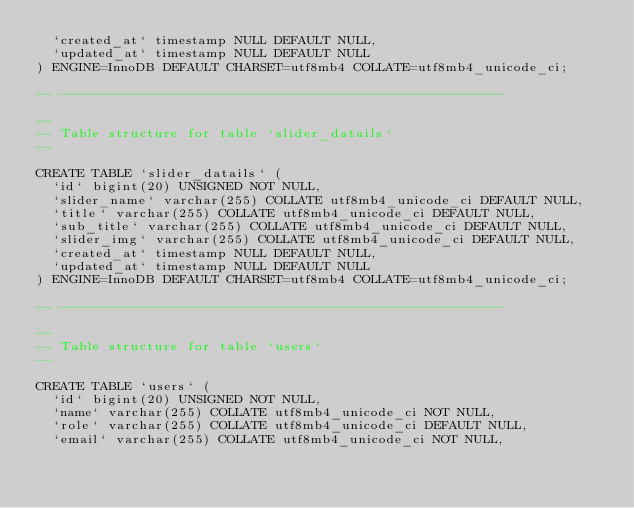<code> <loc_0><loc_0><loc_500><loc_500><_SQL_>  `created_at` timestamp NULL DEFAULT NULL,
  `updated_at` timestamp NULL DEFAULT NULL
) ENGINE=InnoDB DEFAULT CHARSET=utf8mb4 COLLATE=utf8mb4_unicode_ci;

-- --------------------------------------------------------

--
-- Table structure for table `slider_datails`
--

CREATE TABLE `slider_datails` (
  `id` bigint(20) UNSIGNED NOT NULL,
  `slider_name` varchar(255) COLLATE utf8mb4_unicode_ci DEFAULT NULL,
  `title` varchar(255) COLLATE utf8mb4_unicode_ci DEFAULT NULL,
  `sub_title` varchar(255) COLLATE utf8mb4_unicode_ci DEFAULT NULL,
  `slider_img` varchar(255) COLLATE utf8mb4_unicode_ci DEFAULT NULL,
  `created_at` timestamp NULL DEFAULT NULL,
  `updated_at` timestamp NULL DEFAULT NULL
) ENGINE=InnoDB DEFAULT CHARSET=utf8mb4 COLLATE=utf8mb4_unicode_ci;

-- --------------------------------------------------------

--
-- Table structure for table `users`
--

CREATE TABLE `users` (
  `id` bigint(20) UNSIGNED NOT NULL,
  `name` varchar(255) COLLATE utf8mb4_unicode_ci NOT NULL,
  `role` varchar(255) COLLATE utf8mb4_unicode_ci DEFAULT NULL,
  `email` varchar(255) COLLATE utf8mb4_unicode_ci NOT NULL,</code> 